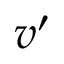<formula> <loc_0><loc_0><loc_500><loc_500>v ^ { \prime }</formula> 